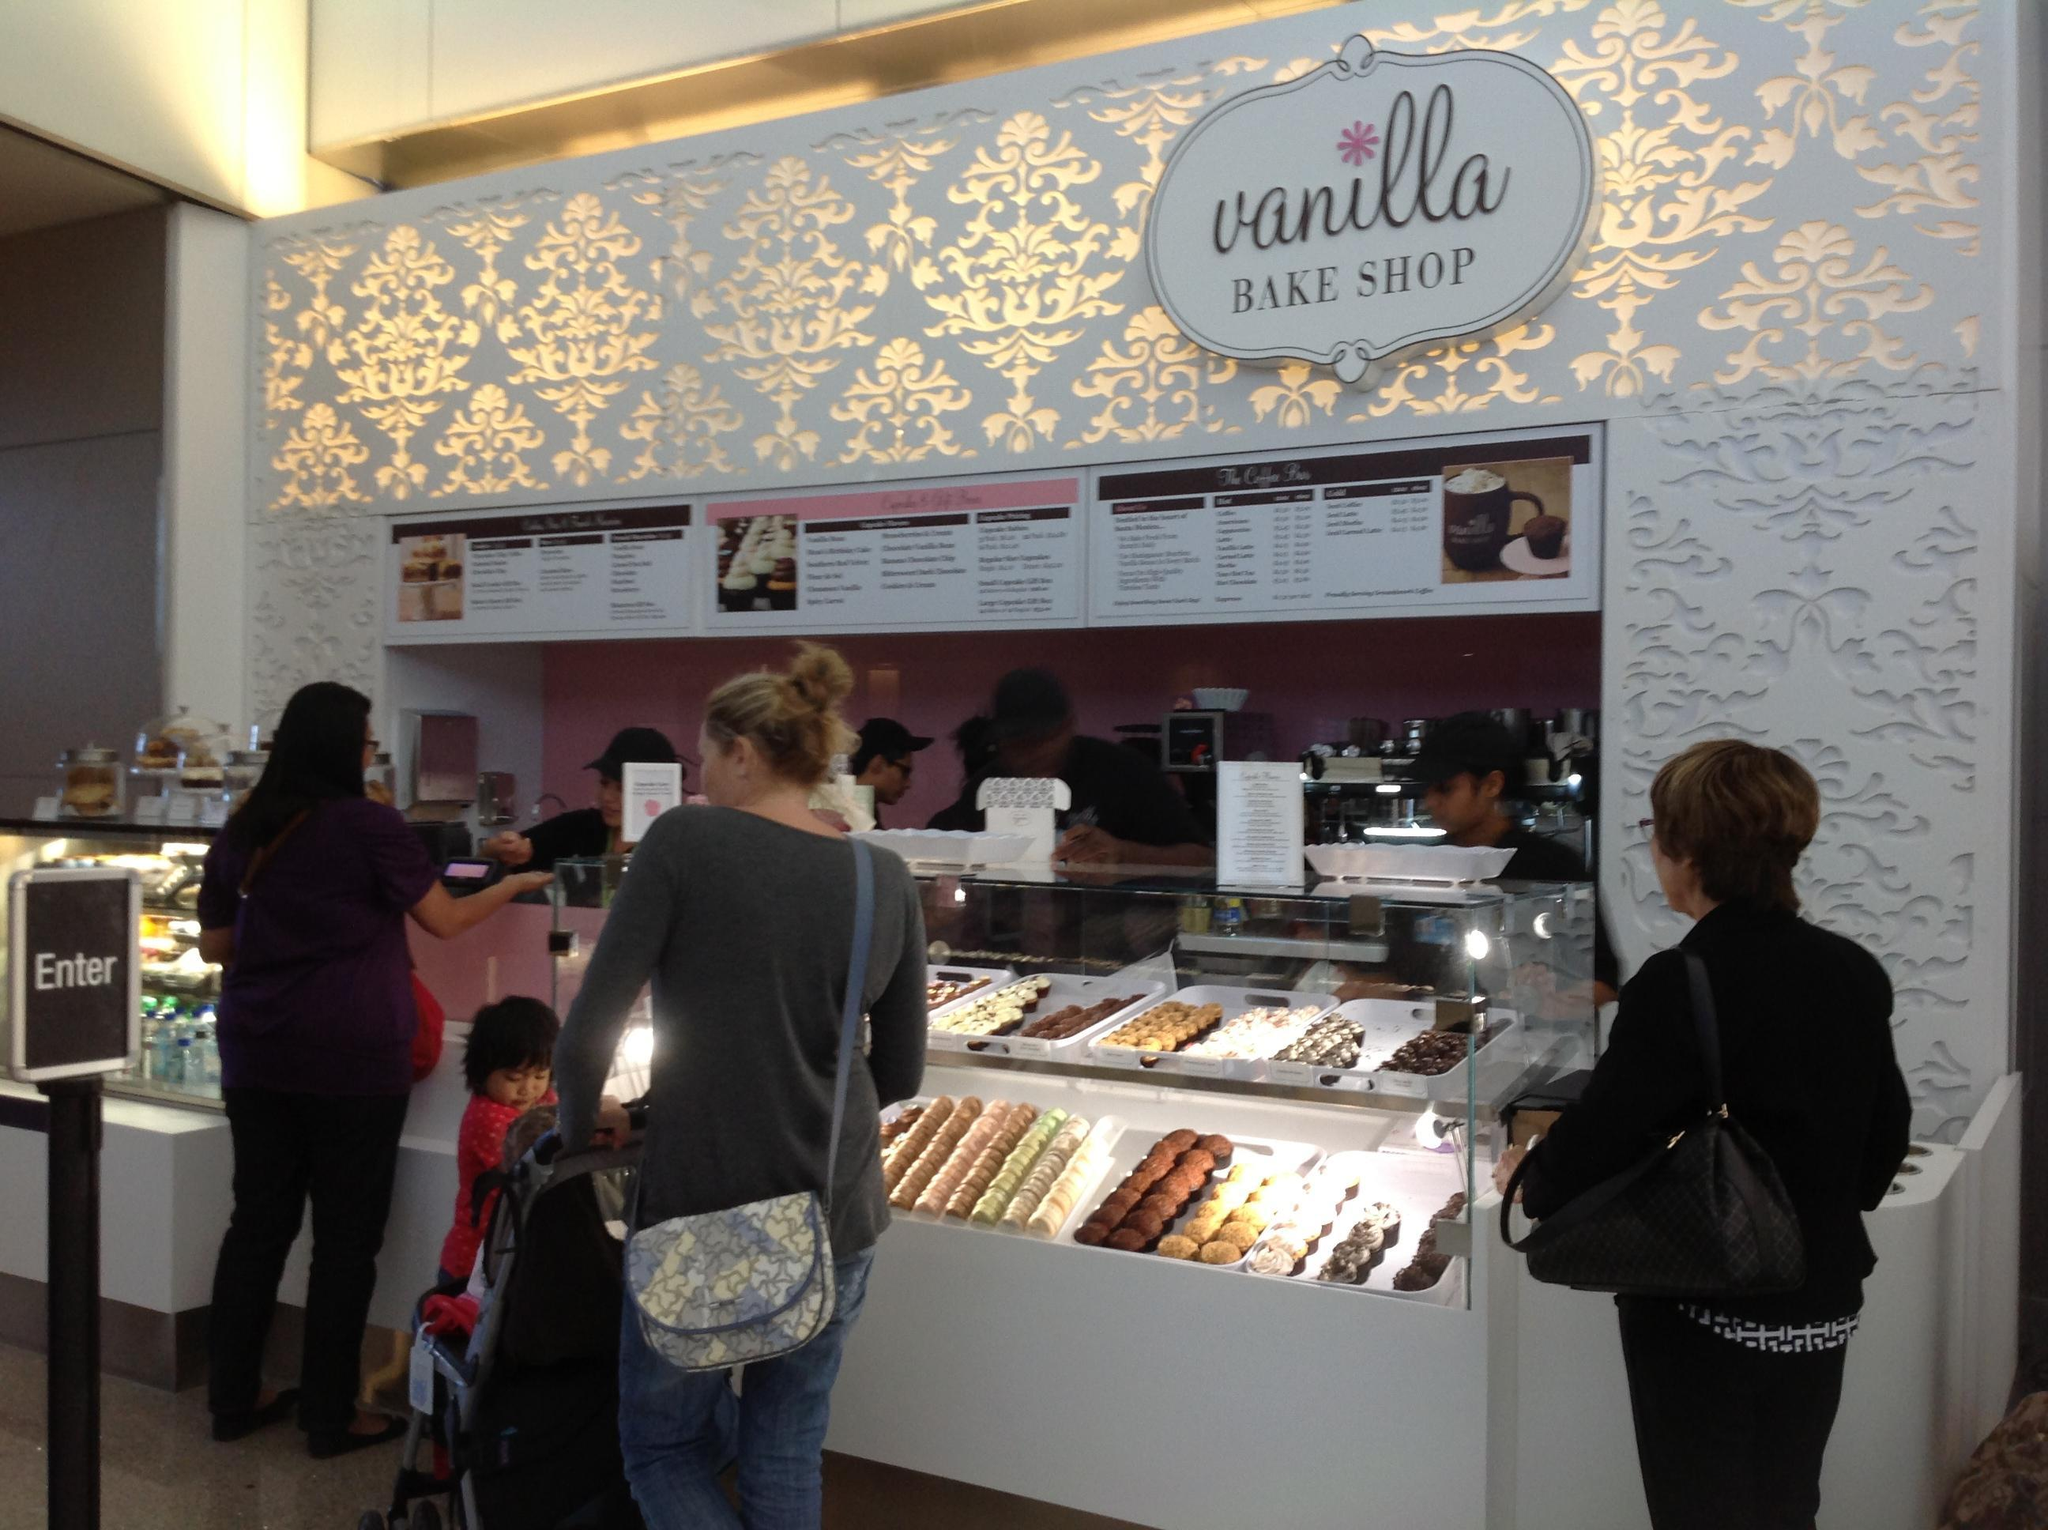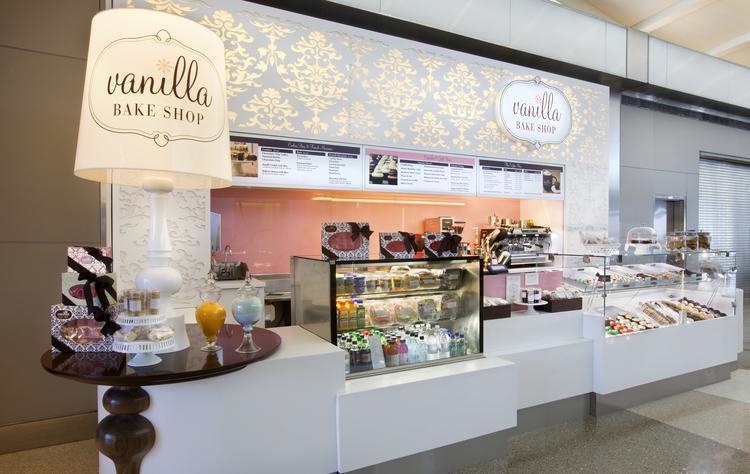The first image is the image on the left, the second image is the image on the right. Analyze the images presented: Is the assertion "There is a lampshade that says """"Vanilla Bake Shop""""" valid? Answer yes or no. Yes. The first image is the image on the left, the second image is the image on the right. Examine the images to the left and right. Is the description "A large table lamp is on top of a brown table next to a display of desserts." accurate? Answer yes or no. Yes. 